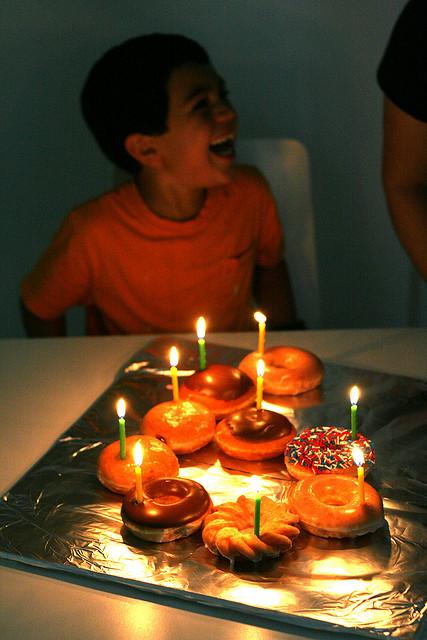Are these cupcakes?
Give a very brief answer. No. Is this a real cake?
Be succinct. No. WHAT color is the boy's shirt?
Write a very short answer. Orange. 